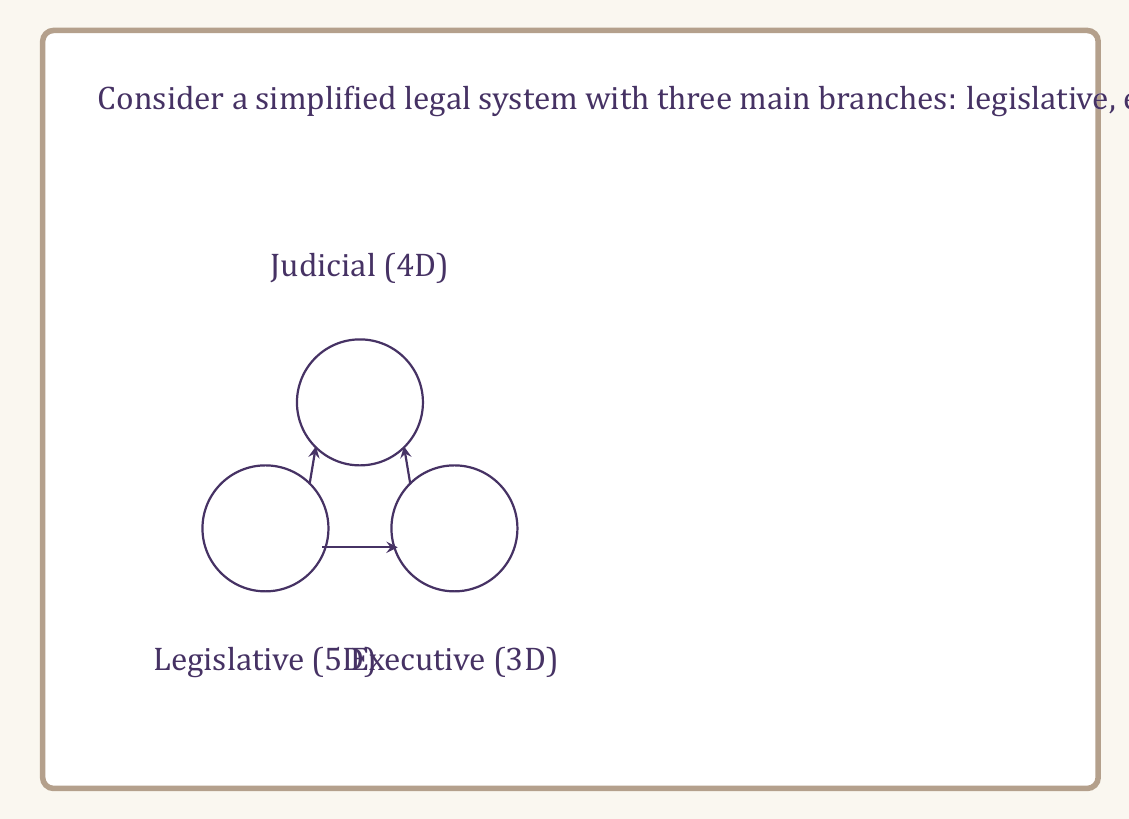What is the answer to this math problem? To solve this problem, we need to understand the concept of product manifolds and how they relate to the topological complexity of systems.

1. Each branch of the legal system is represented as a manifold with its own dimension:
   - Legislative branch: 5-dimensional manifold
   - Executive branch: 3-dimensional manifold
   - Judicial branch: 4-dimensional manifold

2. The interactions between these branches are modeled as a product manifold. In topology, the dimension of a product manifold is the sum of the dimensions of its component manifolds.

3. Let's denote the manifolds as follows:
   $M_L$ : Legislative manifold (5D)
   $M_E$ : Executive manifold (3D)
   $M_J$ : Judicial manifold (4D)

4. The product manifold representing the entire legal system is:
   $M = M_L \times M_E \times M_J$

5. The dimension of the product manifold is the sum of the dimensions of its components:
   $\dim(M) = \dim(M_L) + \dim(M_E) + \dim(M_J)$

6. Substituting the given values:
   $\dim(M) = 5 + 3 + 4 = 12$

Therefore, the total dimension of the legal system manifold is 12.

This higher-dimensional representation captures the complexity of the legal system, where each dimension can represent different aspects such as laws, regulations, precedents, and their interactions.
Answer: 12 